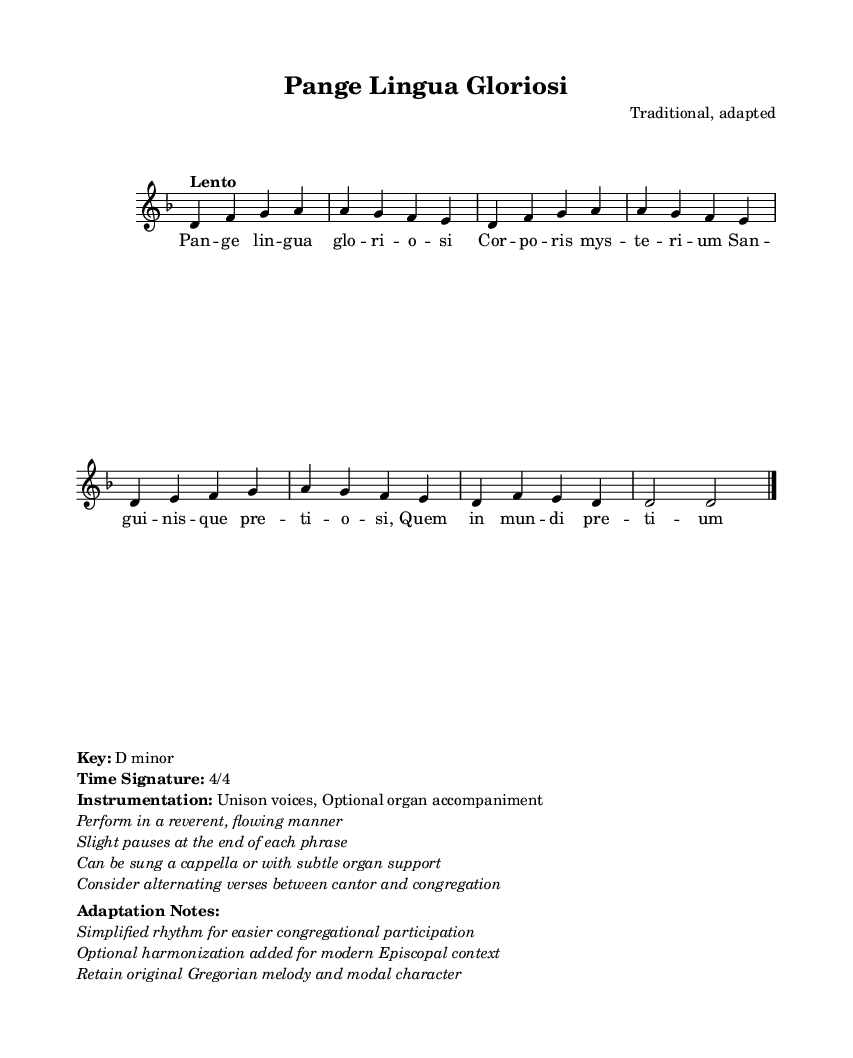What is the key signature of this music? The key signature is D minor, which typically has one flat (B flat) and indicates that the piece is centered around the note D.
Answer: D minor What is the time signature of this music? The time signature is 4/4, which means there are four beats in each measure and a quarter note receives one beat.
Answer: 4/4 What is the tempo marking of this piece? The tempo marking is "Lento", indicating a slow and relaxed pace for the performance of the piece.
Answer: Lento How many lines are there in the melody? The melody consists of one continuous line as indicated by the single voice staff provided in the score.
Answer: One line What kind of vocal arrangement is indicated for this piece? The piece is scored for unison voices, meaning that all singers would sing the same melody without harmony.
Answer: Unison voices What adaptations have been made for modern use? The adaptations include simplified rhythm for easier congregational participation and optional harmonization for the Episcopal context.
Answer: Simplified rhythm and optional harmonization How should this piece be performed regarding the organ? The piece can be sung a cappella or with subtle organ support, suggesting flexibility in its performance context.
Answer: A cappella or with subtle organ support 